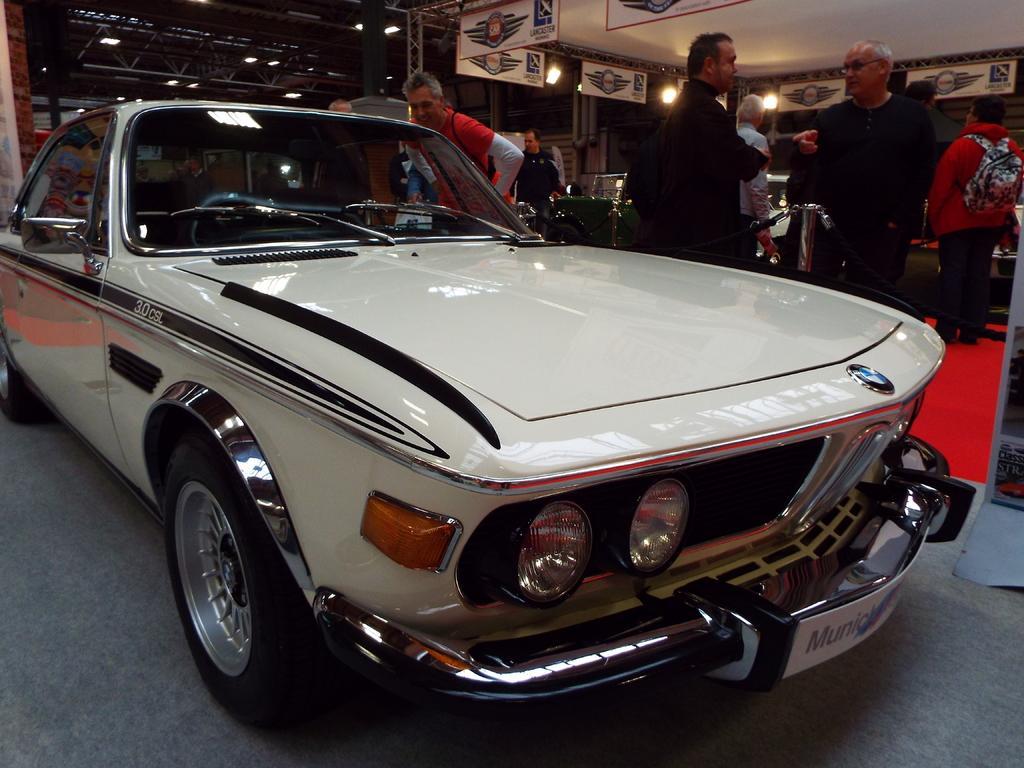Could you give a brief overview of what you see in this image? In this picture we can observe a white color car on the floor. There are some people standing. In the background we can observe white color boards and yellow color lights. 